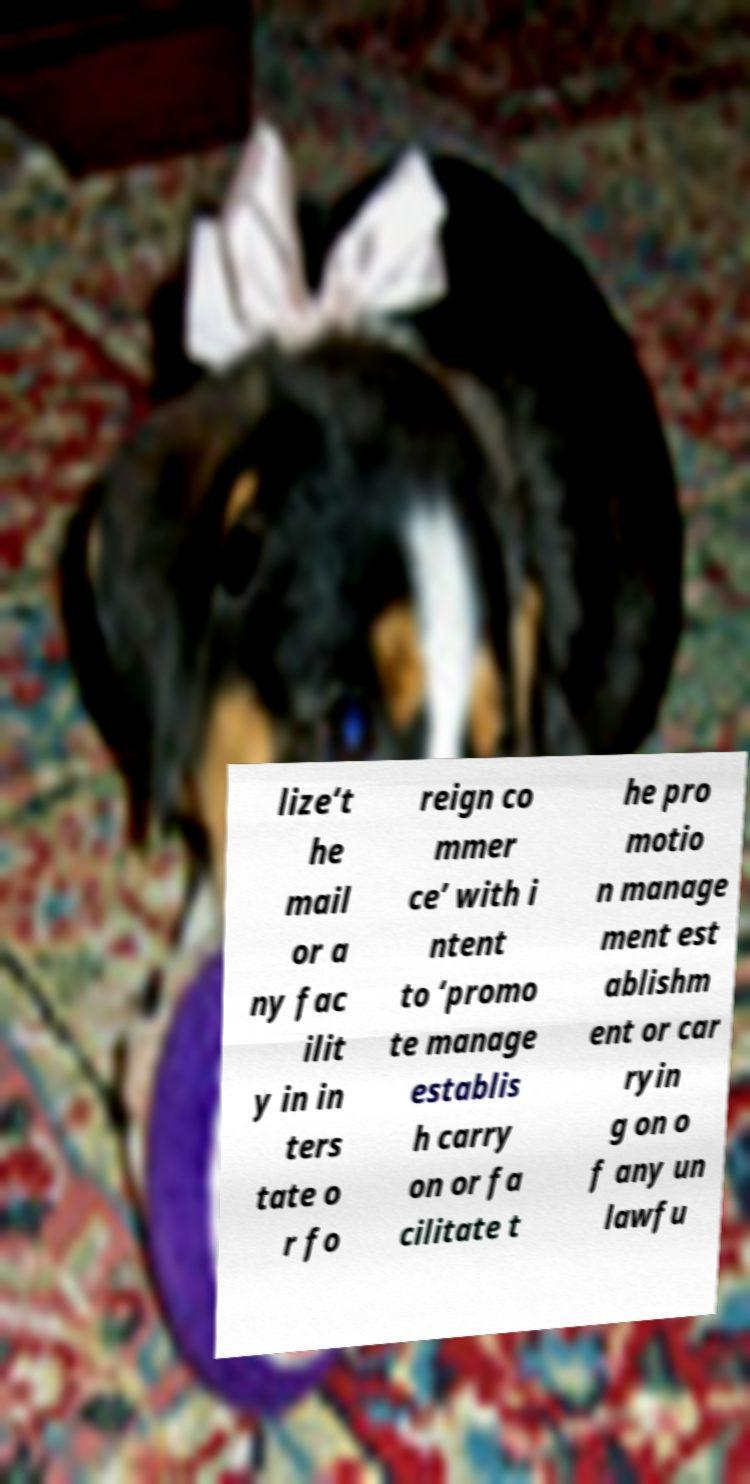Can you accurately transcribe the text from the provided image for me? lize‘t he mail or a ny fac ilit y in in ters tate o r fo reign co mmer ce’ with i ntent to ‘promo te manage establis h carry on or fa cilitate t he pro motio n manage ment est ablishm ent or car ryin g on o f any un lawfu 